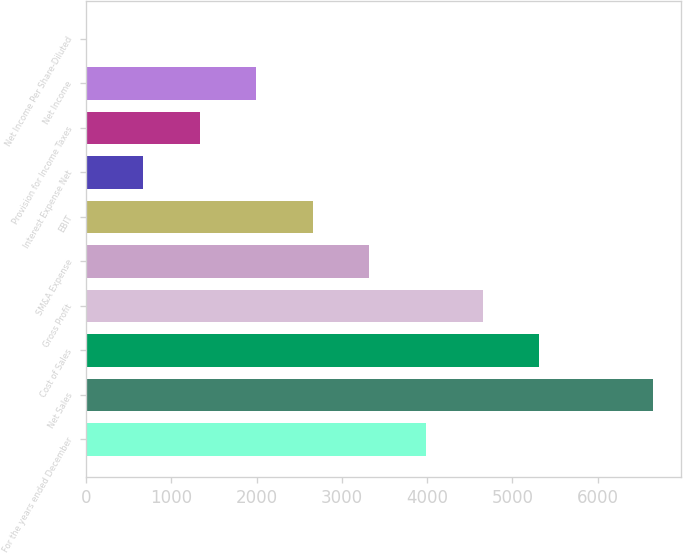Convert chart. <chart><loc_0><loc_0><loc_500><loc_500><bar_chart><fcel>For the years ended December<fcel>Net Sales<fcel>Cost of Sales<fcel>Gross Profit<fcel>SM&A Expense<fcel>EBIT<fcel>Interest Expense Net<fcel>Provision for Income Taxes<fcel>Net Income<fcel>Net Income Per Share-Diluted<nl><fcel>3987.73<fcel>6644.3<fcel>5316.01<fcel>4651.87<fcel>3323.59<fcel>2659.45<fcel>667.03<fcel>1331.17<fcel>1995.31<fcel>2.89<nl></chart> 